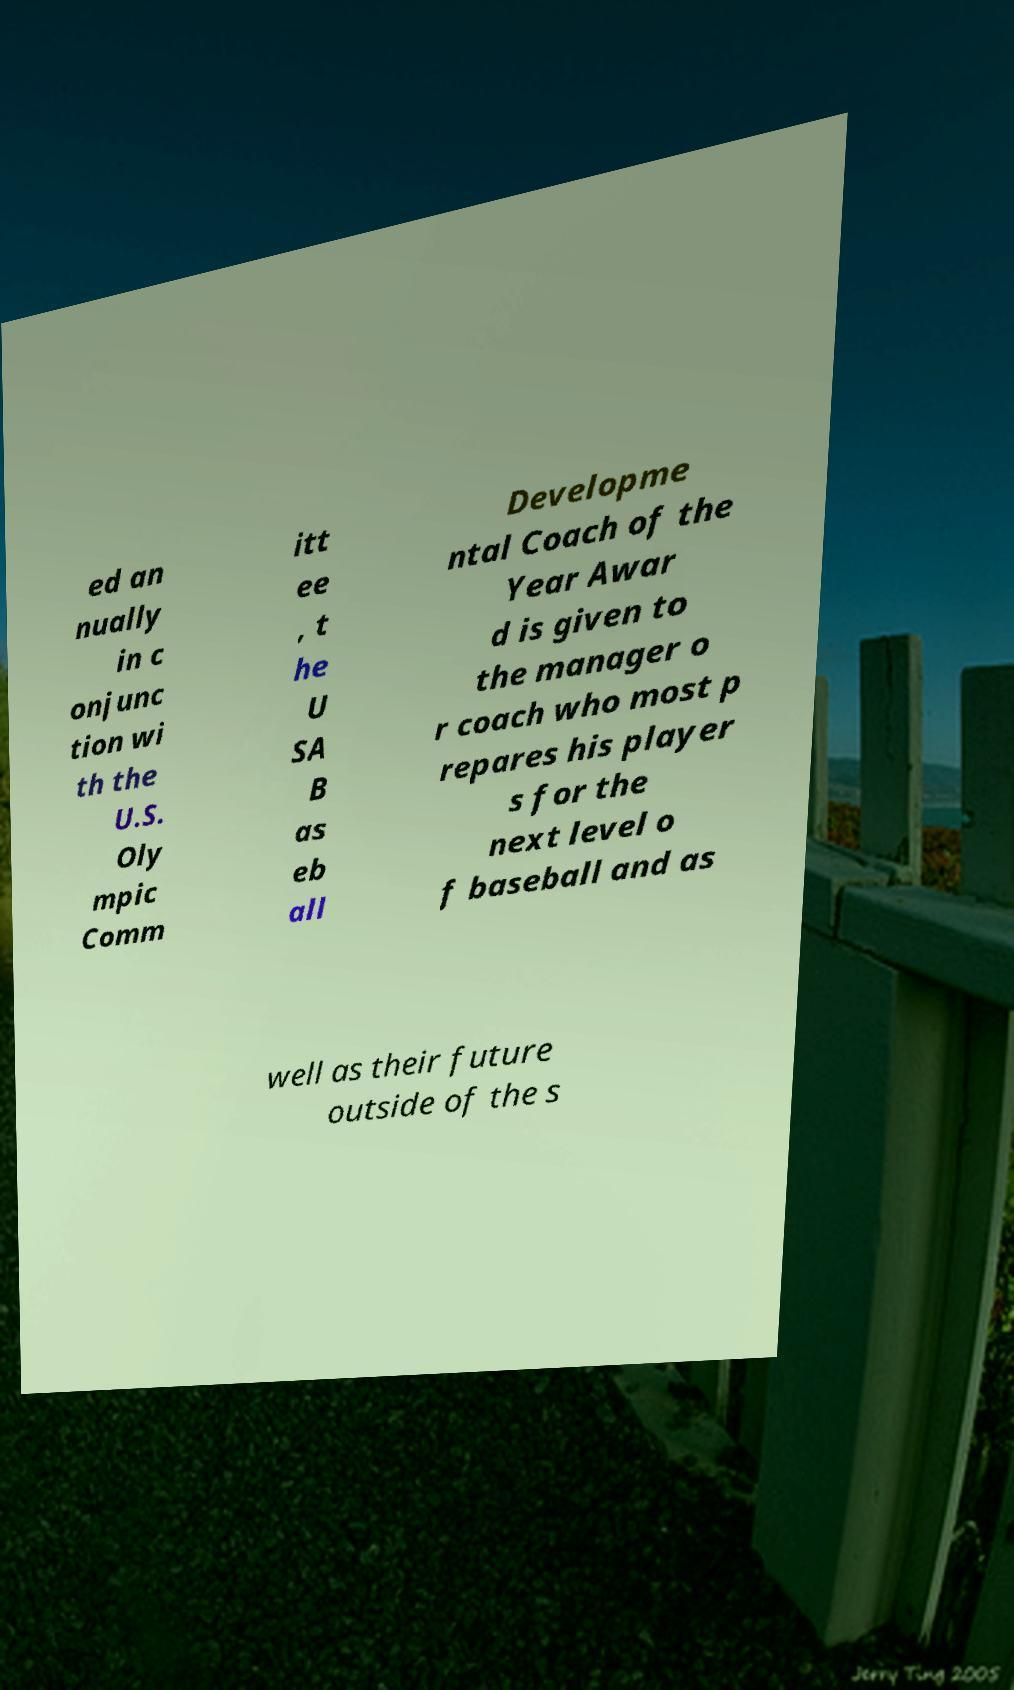Can you read and provide the text displayed in the image?This photo seems to have some interesting text. Can you extract and type it out for me? ed an nually in c onjunc tion wi th the U.S. Oly mpic Comm itt ee , t he U SA B as eb all Developme ntal Coach of the Year Awar d is given to the manager o r coach who most p repares his player s for the next level o f baseball and as well as their future outside of the s 